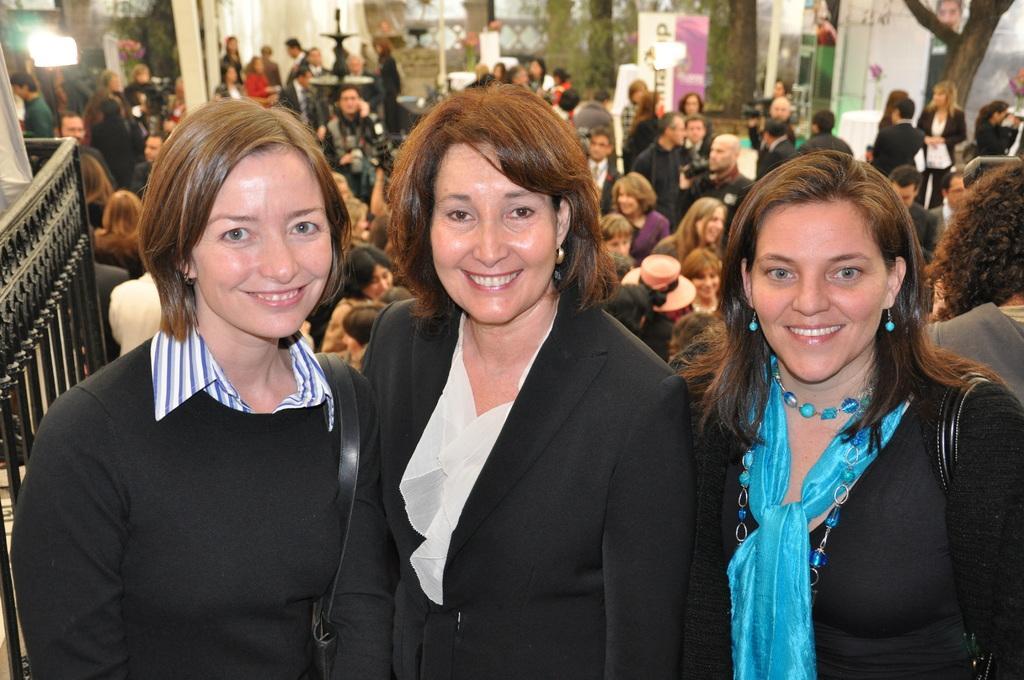Could you give a brief overview of what you see in this image? In this picture I can see three women's, behind we can see some people, and also I can see fence, trees and some glass doors around. 